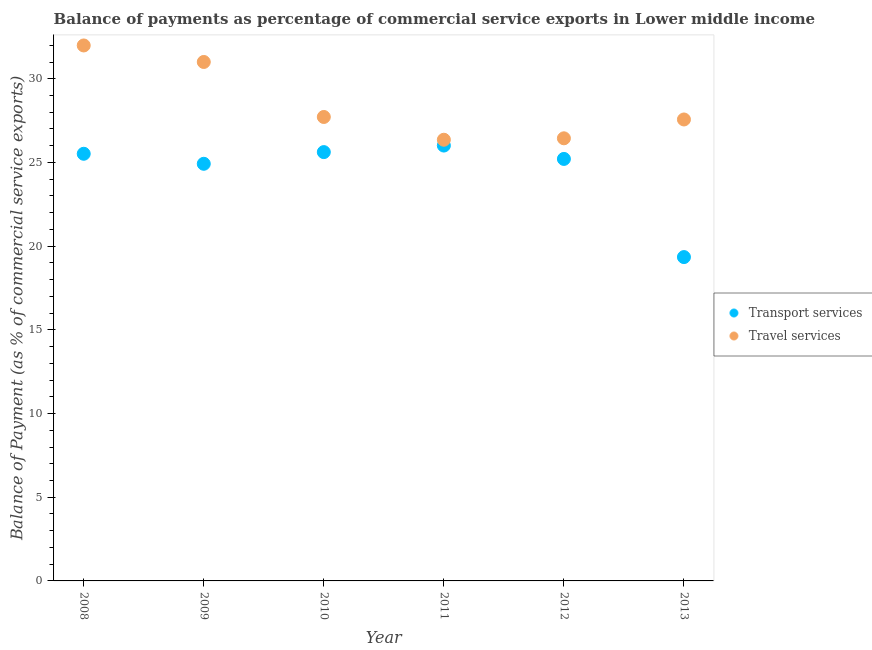Is the number of dotlines equal to the number of legend labels?
Keep it short and to the point. Yes. What is the balance of payments of travel services in 2010?
Give a very brief answer. 27.72. Across all years, what is the maximum balance of payments of transport services?
Ensure brevity in your answer.  26.01. Across all years, what is the minimum balance of payments of travel services?
Give a very brief answer. 26.36. In which year was the balance of payments of travel services maximum?
Offer a terse response. 2008. In which year was the balance of payments of transport services minimum?
Your answer should be compact. 2013. What is the total balance of payments of travel services in the graph?
Keep it short and to the point. 171.08. What is the difference between the balance of payments of transport services in 2009 and that in 2012?
Keep it short and to the point. -0.29. What is the difference between the balance of payments of travel services in 2010 and the balance of payments of transport services in 2009?
Make the answer very short. 2.8. What is the average balance of payments of travel services per year?
Your answer should be compact. 28.51. In the year 2011, what is the difference between the balance of payments of transport services and balance of payments of travel services?
Provide a succinct answer. -0.35. What is the ratio of the balance of payments of transport services in 2011 to that in 2013?
Your response must be concise. 1.34. Is the balance of payments of transport services in 2010 less than that in 2013?
Your answer should be very brief. No. Is the difference between the balance of payments of travel services in 2008 and 2012 greater than the difference between the balance of payments of transport services in 2008 and 2012?
Ensure brevity in your answer.  Yes. What is the difference between the highest and the second highest balance of payments of travel services?
Your response must be concise. 0.99. What is the difference between the highest and the lowest balance of payments of transport services?
Provide a short and direct response. 6.66. Is the sum of the balance of payments of transport services in 2010 and 2012 greater than the maximum balance of payments of travel services across all years?
Give a very brief answer. Yes. Is the balance of payments of travel services strictly less than the balance of payments of transport services over the years?
Your response must be concise. No. How many dotlines are there?
Your response must be concise. 2. How many years are there in the graph?
Provide a succinct answer. 6. Does the graph contain any zero values?
Provide a short and direct response. No. Where does the legend appear in the graph?
Provide a short and direct response. Center right. How many legend labels are there?
Provide a succinct answer. 2. How are the legend labels stacked?
Your answer should be very brief. Vertical. What is the title of the graph?
Your answer should be very brief. Balance of payments as percentage of commercial service exports in Lower middle income. Does "Passenger Transport Items" appear as one of the legend labels in the graph?
Make the answer very short. No. What is the label or title of the Y-axis?
Offer a very short reply. Balance of Payment (as % of commercial service exports). What is the Balance of Payment (as % of commercial service exports) of Transport services in 2008?
Offer a very short reply. 25.52. What is the Balance of Payment (as % of commercial service exports) in Travel services in 2008?
Provide a short and direct response. 31.99. What is the Balance of Payment (as % of commercial service exports) of Transport services in 2009?
Offer a very short reply. 24.92. What is the Balance of Payment (as % of commercial service exports) in Travel services in 2009?
Your answer should be very brief. 31. What is the Balance of Payment (as % of commercial service exports) of Transport services in 2010?
Make the answer very short. 25.62. What is the Balance of Payment (as % of commercial service exports) of Travel services in 2010?
Offer a very short reply. 27.72. What is the Balance of Payment (as % of commercial service exports) in Transport services in 2011?
Keep it short and to the point. 26.01. What is the Balance of Payment (as % of commercial service exports) in Travel services in 2011?
Give a very brief answer. 26.36. What is the Balance of Payment (as % of commercial service exports) of Transport services in 2012?
Give a very brief answer. 25.21. What is the Balance of Payment (as % of commercial service exports) of Travel services in 2012?
Your response must be concise. 26.44. What is the Balance of Payment (as % of commercial service exports) of Transport services in 2013?
Offer a very short reply. 19.35. What is the Balance of Payment (as % of commercial service exports) in Travel services in 2013?
Provide a short and direct response. 27.57. Across all years, what is the maximum Balance of Payment (as % of commercial service exports) of Transport services?
Offer a terse response. 26.01. Across all years, what is the maximum Balance of Payment (as % of commercial service exports) in Travel services?
Provide a succinct answer. 31.99. Across all years, what is the minimum Balance of Payment (as % of commercial service exports) in Transport services?
Offer a terse response. 19.35. Across all years, what is the minimum Balance of Payment (as % of commercial service exports) of Travel services?
Your answer should be compact. 26.36. What is the total Balance of Payment (as % of commercial service exports) in Transport services in the graph?
Ensure brevity in your answer.  146.63. What is the total Balance of Payment (as % of commercial service exports) of Travel services in the graph?
Offer a terse response. 171.08. What is the difference between the Balance of Payment (as % of commercial service exports) in Transport services in 2008 and that in 2009?
Your response must be concise. 0.6. What is the difference between the Balance of Payment (as % of commercial service exports) in Travel services in 2008 and that in 2009?
Offer a terse response. 0.99. What is the difference between the Balance of Payment (as % of commercial service exports) in Transport services in 2008 and that in 2010?
Make the answer very short. -0.1. What is the difference between the Balance of Payment (as % of commercial service exports) in Travel services in 2008 and that in 2010?
Offer a terse response. 4.27. What is the difference between the Balance of Payment (as % of commercial service exports) of Transport services in 2008 and that in 2011?
Make the answer very short. -0.49. What is the difference between the Balance of Payment (as % of commercial service exports) of Travel services in 2008 and that in 2011?
Keep it short and to the point. 5.63. What is the difference between the Balance of Payment (as % of commercial service exports) in Transport services in 2008 and that in 2012?
Your answer should be compact. 0.31. What is the difference between the Balance of Payment (as % of commercial service exports) in Travel services in 2008 and that in 2012?
Offer a very short reply. 5.55. What is the difference between the Balance of Payment (as % of commercial service exports) in Transport services in 2008 and that in 2013?
Give a very brief answer. 6.17. What is the difference between the Balance of Payment (as % of commercial service exports) in Travel services in 2008 and that in 2013?
Make the answer very short. 4.42. What is the difference between the Balance of Payment (as % of commercial service exports) in Transport services in 2009 and that in 2010?
Make the answer very short. -0.7. What is the difference between the Balance of Payment (as % of commercial service exports) of Travel services in 2009 and that in 2010?
Your response must be concise. 3.29. What is the difference between the Balance of Payment (as % of commercial service exports) in Transport services in 2009 and that in 2011?
Provide a succinct answer. -1.09. What is the difference between the Balance of Payment (as % of commercial service exports) of Travel services in 2009 and that in 2011?
Ensure brevity in your answer.  4.65. What is the difference between the Balance of Payment (as % of commercial service exports) of Transport services in 2009 and that in 2012?
Ensure brevity in your answer.  -0.29. What is the difference between the Balance of Payment (as % of commercial service exports) in Travel services in 2009 and that in 2012?
Ensure brevity in your answer.  4.56. What is the difference between the Balance of Payment (as % of commercial service exports) in Transport services in 2009 and that in 2013?
Your answer should be very brief. 5.57. What is the difference between the Balance of Payment (as % of commercial service exports) of Travel services in 2009 and that in 2013?
Your response must be concise. 3.44. What is the difference between the Balance of Payment (as % of commercial service exports) in Transport services in 2010 and that in 2011?
Your answer should be compact. -0.39. What is the difference between the Balance of Payment (as % of commercial service exports) of Travel services in 2010 and that in 2011?
Give a very brief answer. 1.36. What is the difference between the Balance of Payment (as % of commercial service exports) in Transport services in 2010 and that in 2012?
Provide a short and direct response. 0.41. What is the difference between the Balance of Payment (as % of commercial service exports) in Travel services in 2010 and that in 2012?
Ensure brevity in your answer.  1.27. What is the difference between the Balance of Payment (as % of commercial service exports) in Transport services in 2010 and that in 2013?
Ensure brevity in your answer.  6.27. What is the difference between the Balance of Payment (as % of commercial service exports) in Travel services in 2010 and that in 2013?
Provide a succinct answer. 0.15. What is the difference between the Balance of Payment (as % of commercial service exports) in Transport services in 2011 and that in 2012?
Your answer should be very brief. 0.8. What is the difference between the Balance of Payment (as % of commercial service exports) of Travel services in 2011 and that in 2012?
Make the answer very short. -0.09. What is the difference between the Balance of Payment (as % of commercial service exports) in Transport services in 2011 and that in 2013?
Offer a very short reply. 6.66. What is the difference between the Balance of Payment (as % of commercial service exports) in Travel services in 2011 and that in 2013?
Provide a short and direct response. -1.21. What is the difference between the Balance of Payment (as % of commercial service exports) of Transport services in 2012 and that in 2013?
Your answer should be compact. 5.86. What is the difference between the Balance of Payment (as % of commercial service exports) of Travel services in 2012 and that in 2013?
Make the answer very short. -1.13. What is the difference between the Balance of Payment (as % of commercial service exports) in Transport services in 2008 and the Balance of Payment (as % of commercial service exports) in Travel services in 2009?
Give a very brief answer. -5.48. What is the difference between the Balance of Payment (as % of commercial service exports) of Transport services in 2008 and the Balance of Payment (as % of commercial service exports) of Travel services in 2010?
Make the answer very short. -2.2. What is the difference between the Balance of Payment (as % of commercial service exports) in Transport services in 2008 and the Balance of Payment (as % of commercial service exports) in Travel services in 2011?
Your response must be concise. -0.84. What is the difference between the Balance of Payment (as % of commercial service exports) of Transport services in 2008 and the Balance of Payment (as % of commercial service exports) of Travel services in 2012?
Your answer should be very brief. -0.92. What is the difference between the Balance of Payment (as % of commercial service exports) of Transport services in 2008 and the Balance of Payment (as % of commercial service exports) of Travel services in 2013?
Make the answer very short. -2.05. What is the difference between the Balance of Payment (as % of commercial service exports) of Transport services in 2009 and the Balance of Payment (as % of commercial service exports) of Travel services in 2010?
Provide a succinct answer. -2.8. What is the difference between the Balance of Payment (as % of commercial service exports) in Transport services in 2009 and the Balance of Payment (as % of commercial service exports) in Travel services in 2011?
Provide a short and direct response. -1.44. What is the difference between the Balance of Payment (as % of commercial service exports) in Transport services in 2009 and the Balance of Payment (as % of commercial service exports) in Travel services in 2012?
Your answer should be compact. -1.52. What is the difference between the Balance of Payment (as % of commercial service exports) in Transport services in 2009 and the Balance of Payment (as % of commercial service exports) in Travel services in 2013?
Your answer should be compact. -2.65. What is the difference between the Balance of Payment (as % of commercial service exports) in Transport services in 2010 and the Balance of Payment (as % of commercial service exports) in Travel services in 2011?
Offer a terse response. -0.74. What is the difference between the Balance of Payment (as % of commercial service exports) in Transport services in 2010 and the Balance of Payment (as % of commercial service exports) in Travel services in 2012?
Your answer should be compact. -0.82. What is the difference between the Balance of Payment (as % of commercial service exports) of Transport services in 2010 and the Balance of Payment (as % of commercial service exports) of Travel services in 2013?
Ensure brevity in your answer.  -1.95. What is the difference between the Balance of Payment (as % of commercial service exports) of Transport services in 2011 and the Balance of Payment (as % of commercial service exports) of Travel services in 2012?
Ensure brevity in your answer.  -0.43. What is the difference between the Balance of Payment (as % of commercial service exports) in Transport services in 2011 and the Balance of Payment (as % of commercial service exports) in Travel services in 2013?
Offer a very short reply. -1.56. What is the difference between the Balance of Payment (as % of commercial service exports) of Transport services in 2012 and the Balance of Payment (as % of commercial service exports) of Travel services in 2013?
Keep it short and to the point. -2.36. What is the average Balance of Payment (as % of commercial service exports) in Transport services per year?
Your answer should be very brief. 24.44. What is the average Balance of Payment (as % of commercial service exports) in Travel services per year?
Keep it short and to the point. 28.51. In the year 2008, what is the difference between the Balance of Payment (as % of commercial service exports) of Transport services and Balance of Payment (as % of commercial service exports) of Travel services?
Your answer should be compact. -6.47. In the year 2009, what is the difference between the Balance of Payment (as % of commercial service exports) of Transport services and Balance of Payment (as % of commercial service exports) of Travel services?
Ensure brevity in your answer.  -6.08. In the year 2010, what is the difference between the Balance of Payment (as % of commercial service exports) of Transport services and Balance of Payment (as % of commercial service exports) of Travel services?
Offer a very short reply. -2.1. In the year 2011, what is the difference between the Balance of Payment (as % of commercial service exports) in Transport services and Balance of Payment (as % of commercial service exports) in Travel services?
Make the answer very short. -0.35. In the year 2012, what is the difference between the Balance of Payment (as % of commercial service exports) in Transport services and Balance of Payment (as % of commercial service exports) in Travel services?
Make the answer very short. -1.23. In the year 2013, what is the difference between the Balance of Payment (as % of commercial service exports) in Transport services and Balance of Payment (as % of commercial service exports) in Travel services?
Your response must be concise. -8.22. What is the ratio of the Balance of Payment (as % of commercial service exports) in Transport services in 2008 to that in 2009?
Ensure brevity in your answer.  1.02. What is the ratio of the Balance of Payment (as % of commercial service exports) of Travel services in 2008 to that in 2009?
Provide a short and direct response. 1.03. What is the ratio of the Balance of Payment (as % of commercial service exports) of Transport services in 2008 to that in 2010?
Keep it short and to the point. 1. What is the ratio of the Balance of Payment (as % of commercial service exports) in Travel services in 2008 to that in 2010?
Offer a very short reply. 1.15. What is the ratio of the Balance of Payment (as % of commercial service exports) in Transport services in 2008 to that in 2011?
Keep it short and to the point. 0.98. What is the ratio of the Balance of Payment (as % of commercial service exports) of Travel services in 2008 to that in 2011?
Your answer should be compact. 1.21. What is the ratio of the Balance of Payment (as % of commercial service exports) in Transport services in 2008 to that in 2012?
Offer a very short reply. 1.01. What is the ratio of the Balance of Payment (as % of commercial service exports) of Travel services in 2008 to that in 2012?
Give a very brief answer. 1.21. What is the ratio of the Balance of Payment (as % of commercial service exports) of Transport services in 2008 to that in 2013?
Your response must be concise. 1.32. What is the ratio of the Balance of Payment (as % of commercial service exports) in Travel services in 2008 to that in 2013?
Offer a very short reply. 1.16. What is the ratio of the Balance of Payment (as % of commercial service exports) in Transport services in 2009 to that in 2010?
Your response must be concise. 0.97. What is the ratio of the Balance of Payment (as % of commercial service exports) of Travel services in 2009 to that in 2010?
Your answer should be compact. 1.12. What is the ratio of the Balance of Payment (as % of commercial service exports) of Transport services in 2009 to that in 2011?
Give a very brief answer. 0.96. What is the ratio of the Balance of Payment (as % of commercial service exports) of Travel services in 2009 to that in 2011?
Your answer should be very brief. 1.18. What is the ratio of the Balance of Payment (as % of commercial service exports) of Travel services in 2009 to that in 2012?
Your response must be concise. 1.17. What is the ratio of the Balance of Payment (as % of commercial service exports) of Transport services in 2009 to that in 2013?
Your answer should be very brief. 1.29. What is the ratio of the Balance of Payment (as % of commercial service exports) in Travel services in 2009 to that in 2013?
Keep it short and to the point. 1.12. What is the ratio of the Balance of Payment (as % of commercial service exports) of Transport services in 2010 to that in 2011?
Offer a very short reply. 0.98. What is the ratio of the Balance of Payment (as % of commercial service exports) in Travel services in 2010 to that in 2011?
Provide a short and direct response. 1.05. What is the ratio of the Balance of Payment (as % of commercial service exports) in Transport services in 2010 to that in 2012?
Your answer should be compact. 1.02. What is the ratio of the Balance of Payment (as % of commercial service exports) of Travel services in 2010 to that in 2012?
Your answer should be compact. 1.05. What is the ratio of the Balance of Payment (as % of commercial service exports) of Transport services in 2010 to that in 2013?
Provide a succinct answer. 1.32. What is the ratio of the Balance of Payment (as % of commercial service exports) of Travel services in 2010 to that in 2013?
Your answer should be compact. 1.01. What is the ratio of the Balance of Payment (as % of commercial service exports) in Transport services in 2011 to that in 2012?
Your answer should be compact. 1.03. What is the ratio of the Balance of Payment (as % of commercial service exports) of Travel services in 2011 to that in 2012?
Provide a short and direct response. 1. What is the ratio of the Balance of Payment (as % of commercial service exports) in Transport services in 2011 to that in 2013?
Your response must be concise. 1.34. What is the ratio of the Balance of Payment (as % of commercial service exports) of Travel services in 2011 to that in 2013?
Keep it short and to the point. 0.96. What is the ratio of the Balance of Payment (as % of commercial service exports) of Transport services in 2012 to that in 2013?
Give a very brief answer. 1.3. What is the ratio of the Balance of Payment (as % of commercial service exports) in Travel services in 2012 to that in 2013?
Ensure brevity in your answer.  0.96. What is the difference between the highest and the second highest Balance of Payment (as % of commercial service exports) in Transport services?
Offer a very short reply. 0.39. What is the difference between the highest and the second highest Balance of Payment (as % of commercial service exports) of Travel services?
Offer a very short reply. 0.99. What is the difference between the highest and the lowest Balance of Payment (as % of commercial service exports) in Transport services?
Your answer should be compact. 6.66. What is the difference between the highest and the lowest Balance of Payment (as % of commercial service exports) in Travel services?
Offer a very short reply. 5.63. 